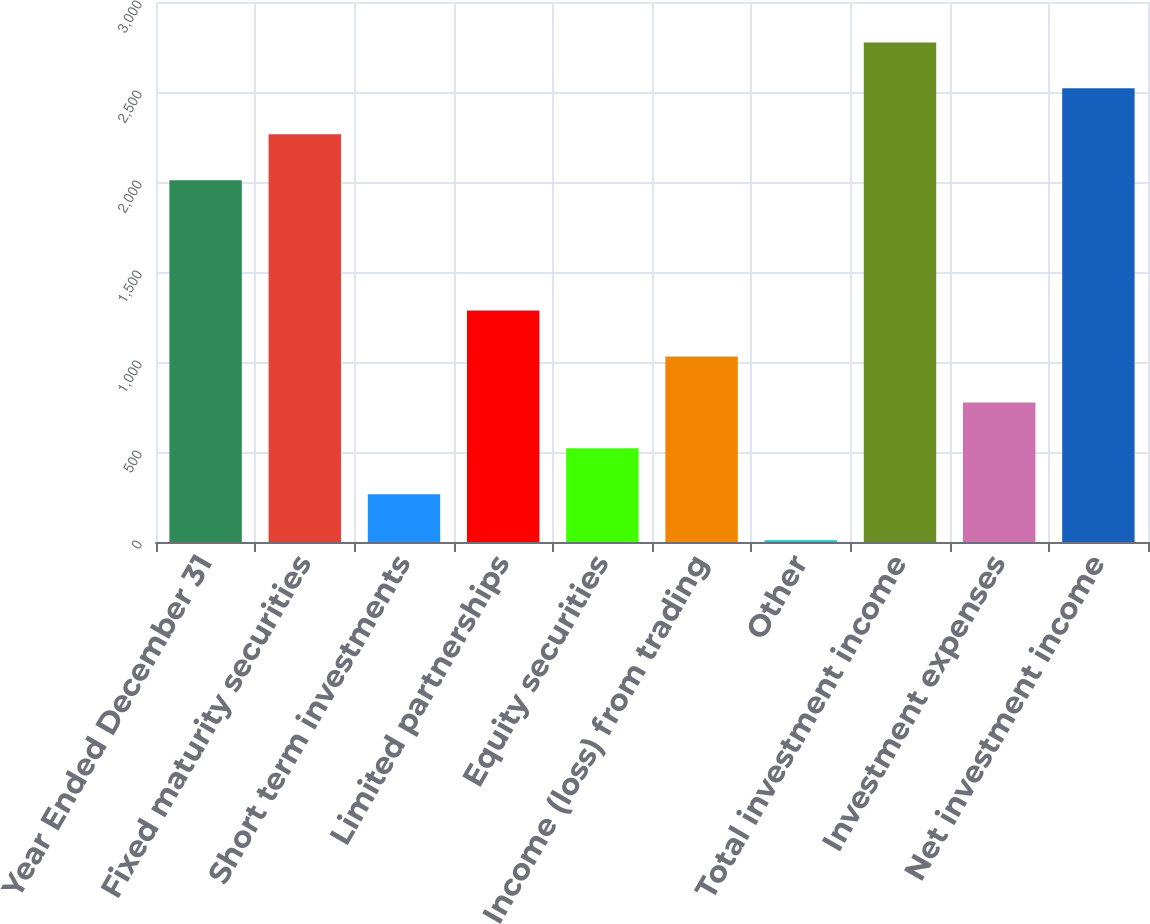<chart> <loc_0><loc_0><loc_500><loc_500><bar_chart><fcel>Year Ended December 31<fcel>Fixed maturity securities<fcel>Short term investments<fcel>Limited partnerships<fcel>Equity securities<fcel>Income (loss) from trading<fcel>Other<fcel>Total investment income<fcel>Investment expenses<fcel>Net investment income<nl><fcel>2010<fcel>2265.2<fcel>265.2<fcel>1286<fcel>520.4<fcel>1030.8<fcel>10<fcel>2775.6<fcel>775.6<fcel>2520.4<nl></chart> 